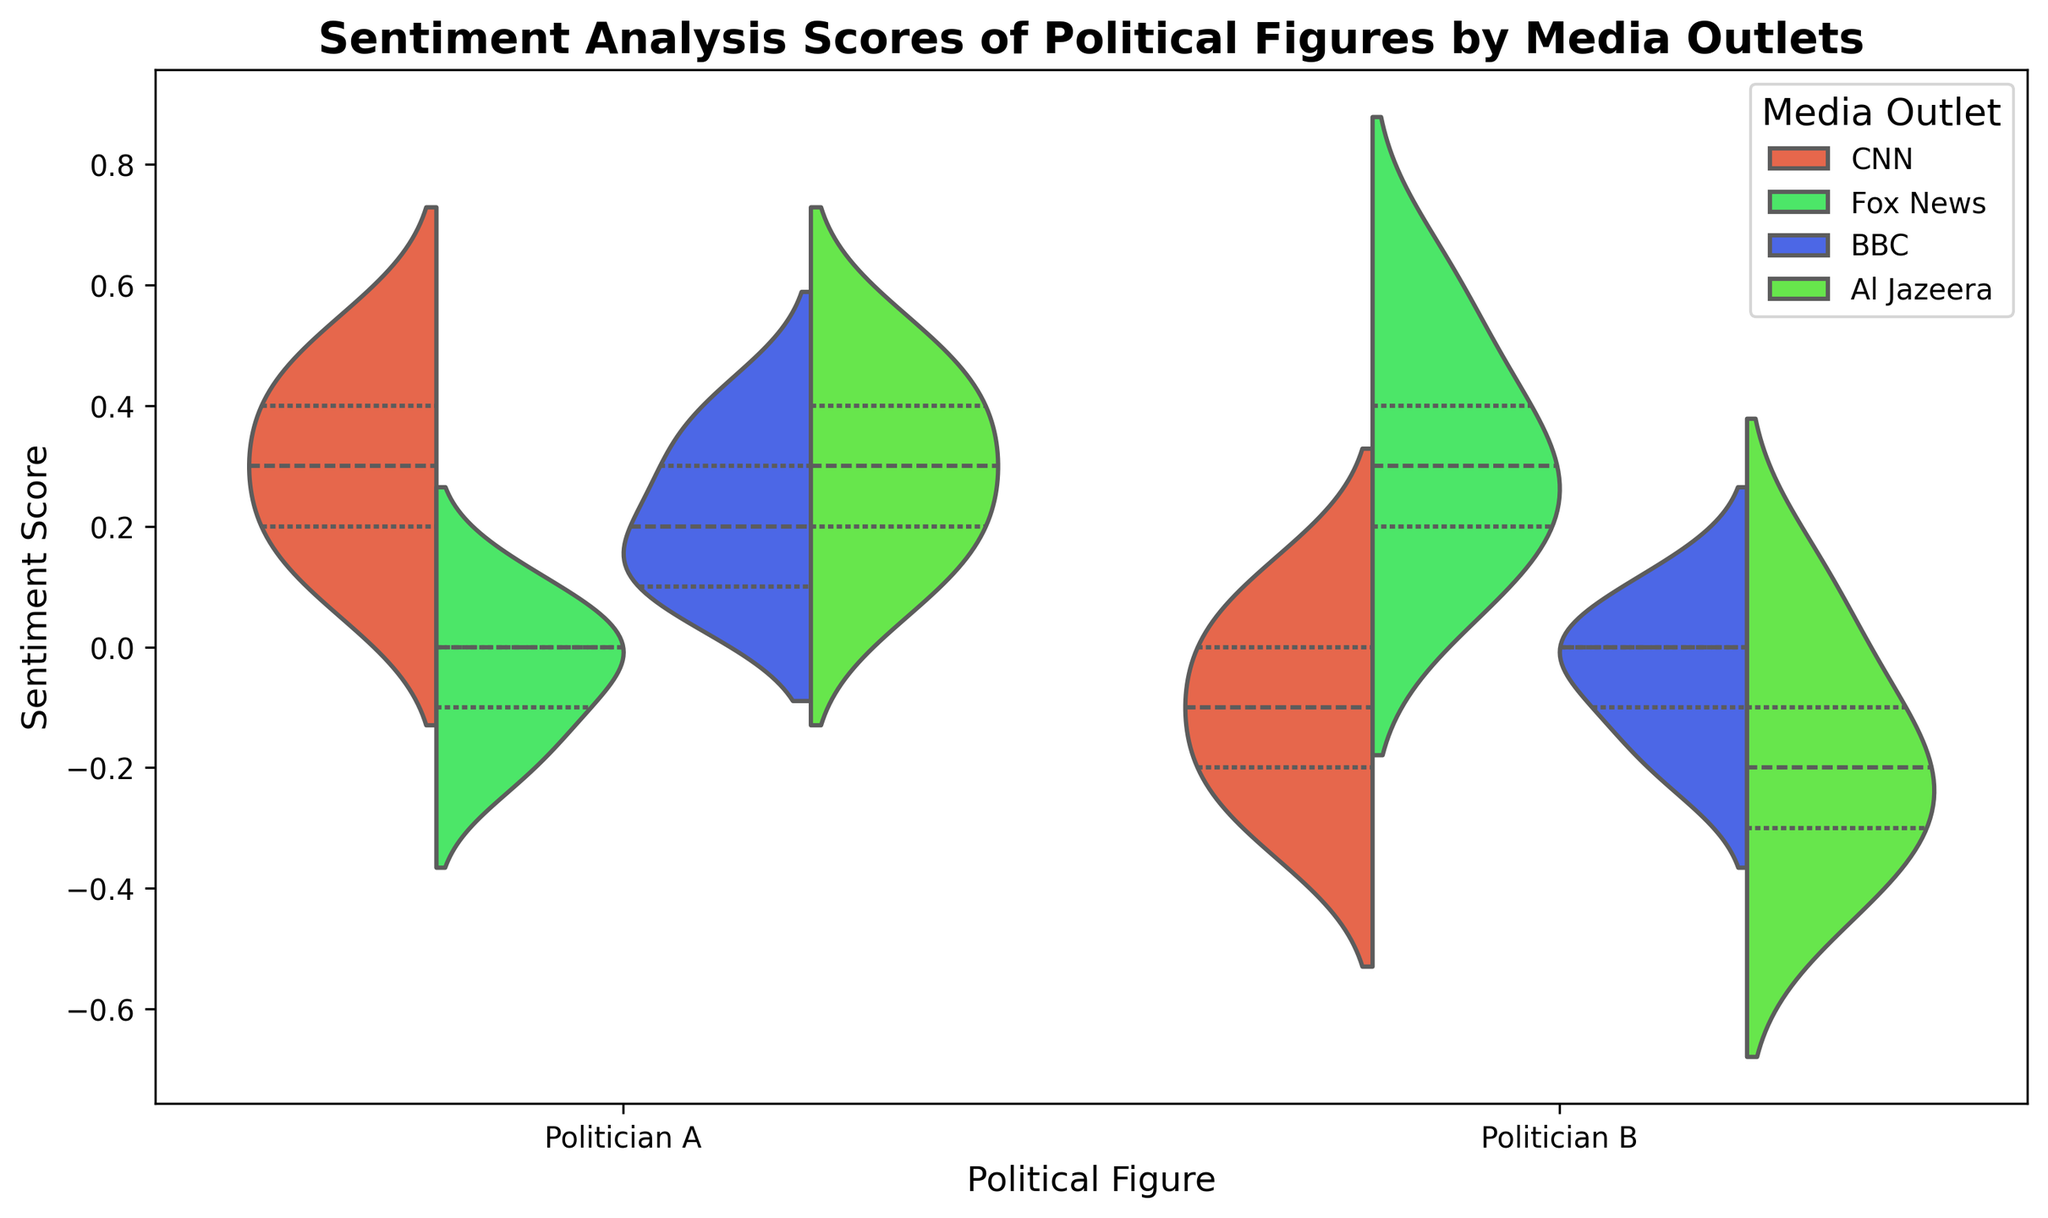What are the sentiment score ranges for Politician A and Politician B on CNN? By observing the spread of the data points in the violin plot, we can determine the sentiment score ranges. For Politician A, the range appears to be from 0.1 to 0.5. For Politician B, the range is from -0.3 to 0.1.
Answer: Politician A: 0.1 to 0.5, Politician B: -0.3 to 0.1 Which media outlet exhibits the most positive sentiment scores for Politician A? By comparing the peaks of the violins for Politician A across different media outlets, Al Jazeera has the most positive sentiment scores with values reaching up to 0.5.
Answer: Al Jazeera Which media outlet shows the widest range of sentiment scores for Politician B? By observing the width of the violins for Politician B, Fox News has the widest range of sentiment scores, from 0.1 to 0.6, indicating a more varied sentiment.
Answer: Fox News How does the median sentiment score for Politician A compare across different media outlets? The median sentiment scores are represented by the central lines inside the violins. Across CNN, BBC, and Al Jazeera, the median is around 0.2 to 0.3. In contrast, Fox News shows a slight negative or neutral median.
Answer: Comparable across CNN, BBC, and Al Jazeera; lower for Fox News Which media outlet displays more negative sentiment scores for Politician B compared to positive ones? By noticing the density of the violin curves for Politician B, Al Jazeera displays more negative sentiment scores, as the violin leans toward negative values.
Answer: Al Jazeera What is the interquartile range (IQR) for Politician B on BBC? The interquartile range is the middle 50% of the data. For BBC, Politician B's IQR can be measured from the bounds of the thicker regions of the violin, which appears to be from approximately -0.1 to 0.0.
Answer: -0.1 to 0.0 Compare the sentiment distributions of Politician A on CNN and Fox News. By observing the shapes of the violins, CNN shows a generally positive trend for Politician A with sentiment scores ranging from 0.1 to 0.5. Conversely, Fox News displays a balanced sentiment profile with scores centering around -0.1 to 0.1.
Answer: CNN: Positive, Fox News: Neutral Which political figure receives the most negative media coverage overall? By comparing the lowest points on the violins for each figure across all media outlets, Politician B receives the most negative media coverage, particularly on CNN and Al Jazeera.
Answer: Politician B 